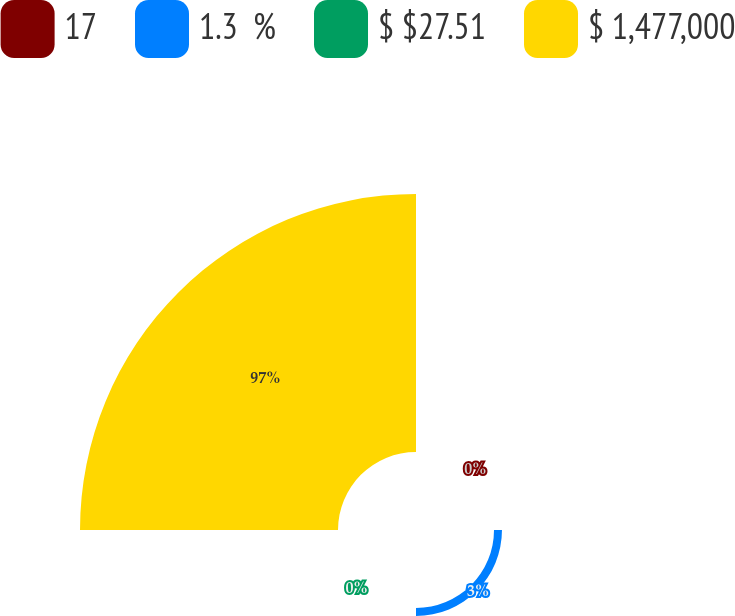Convert chart to OTSL. <chart><loc_0><loc_0><loc_500><loc_500><pie_chart><fcel>17<fcel>1.3  %<fcel>$ $27.51<fcel>$ 1,477,000<nl><fcel>0.0%<fcel>3.0%<fcel>0.0%<fcel>97.0%<nl></chart> 